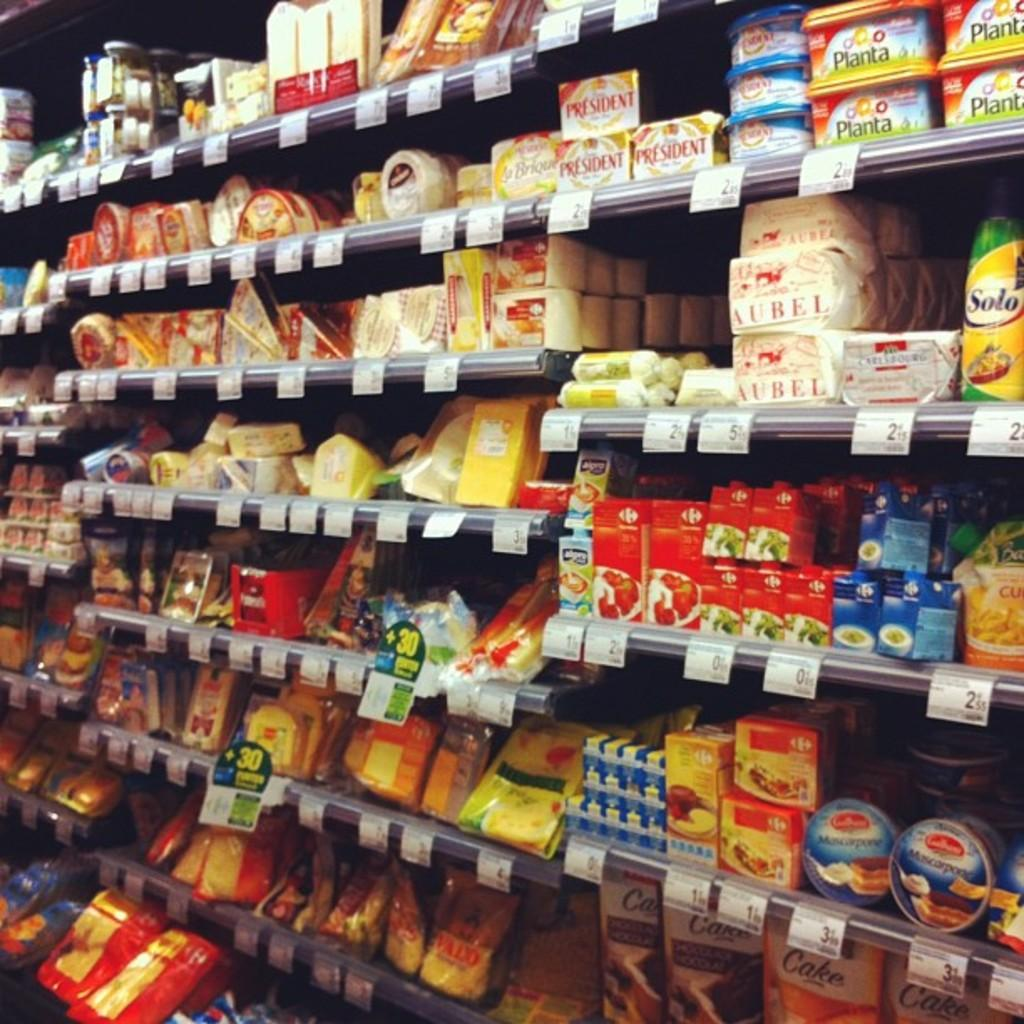Provide a one-sentence caption for the provided image. a grocery shelf is stocked with many items including marscapone cookies in a tin. 